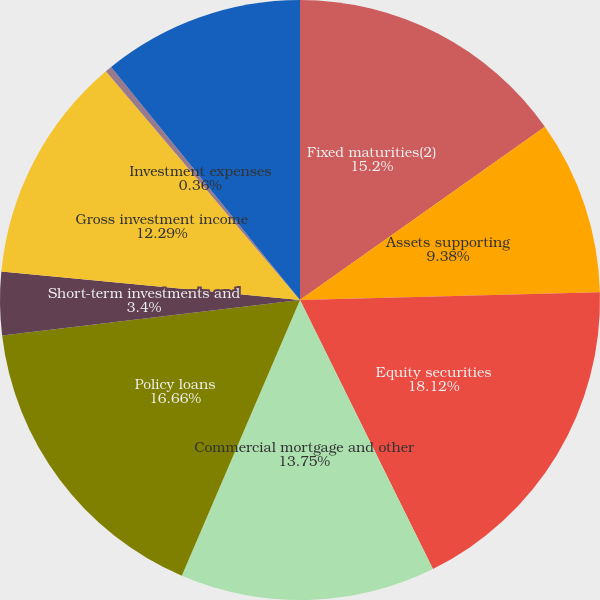Convert chart to OTSL. <chart><loc_0><loc_0><loc_500><loc_500><pie_chart><fcel>Fixed maturities(2)<fcel>Assets supporting<fcel>Equity securities<fcel>Commercial mortgage and other<fcel>Policy loans<fcel>Short-term investments and<fcel>Gross investment income<fcel>Investment expenses<fcel>Investment income after<nl><fcel>15.2%<fcel>9.38%<fcel>18.11%<fcel>13.75%<fcel>16.66%<fcel>3.4%<fcel>12.29%<fcel>0.36%<fcel>10.84%<nl></chart> 